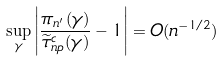Convert formula to latex. <formula><loc_0><loc_0><loc_500><loc_500>\sup _ { \gamma } \left | \frac { \pi _ { n ^ { \prime } } ( \gamma ) } { \widetilde { \tau } _ { n p } ^ { c } ( \gamma ) } - 1 \right | = O ( n ^ { - 1 / 2 } )</formula> 